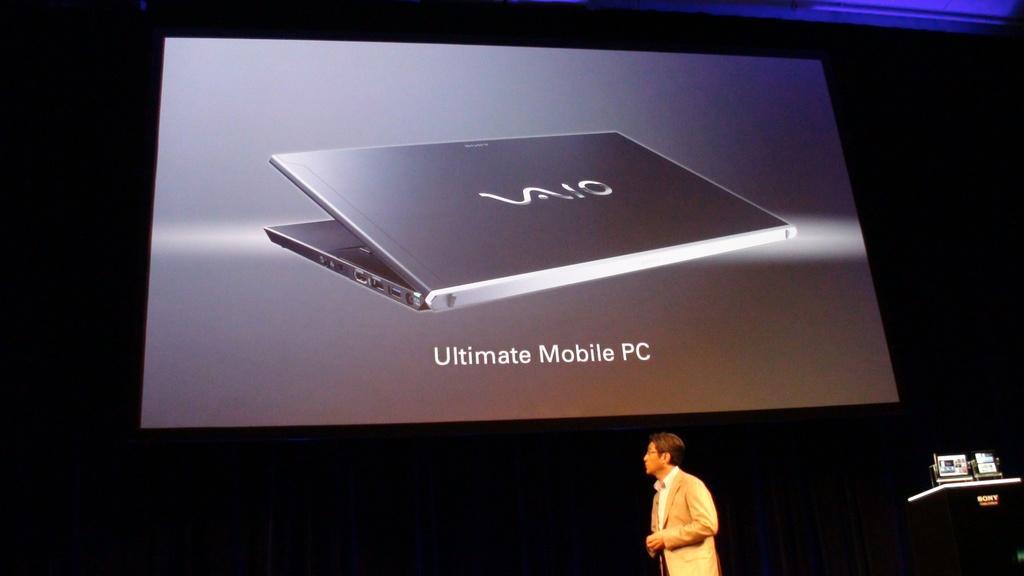How would you summarize this image in a sentence or two? In the center of the image a screen is present. On screen we can a laptop. At the bottom of the image a man is standing. At the bottom right corner podium is present. 